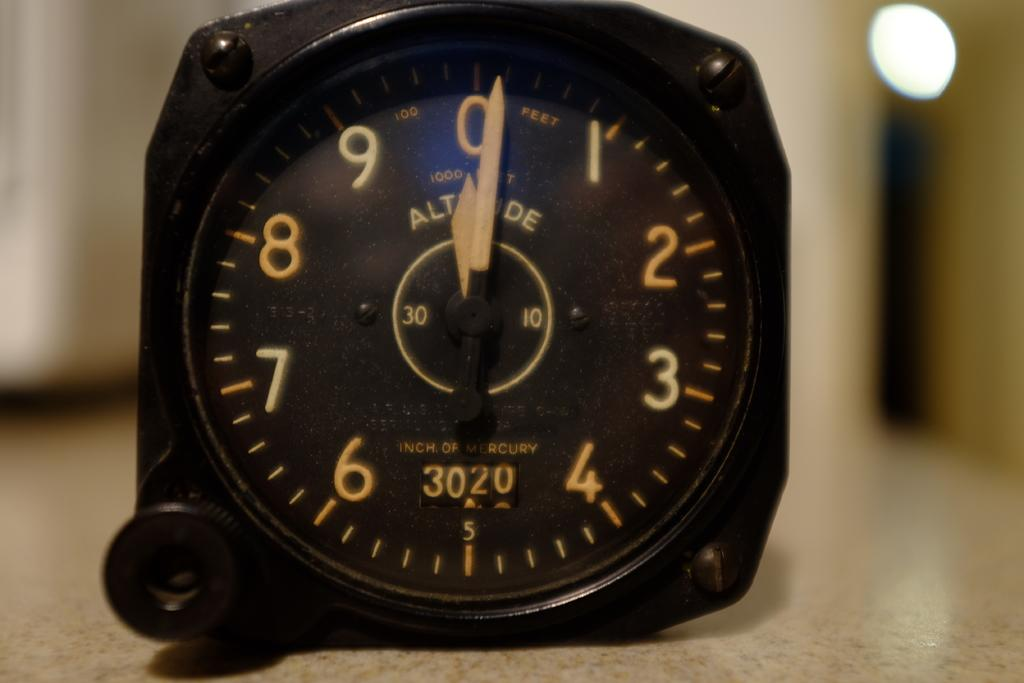Provide a one-sentence caption for the provided image. A black watch showing 3020 inches of mercury on the bottom half. 